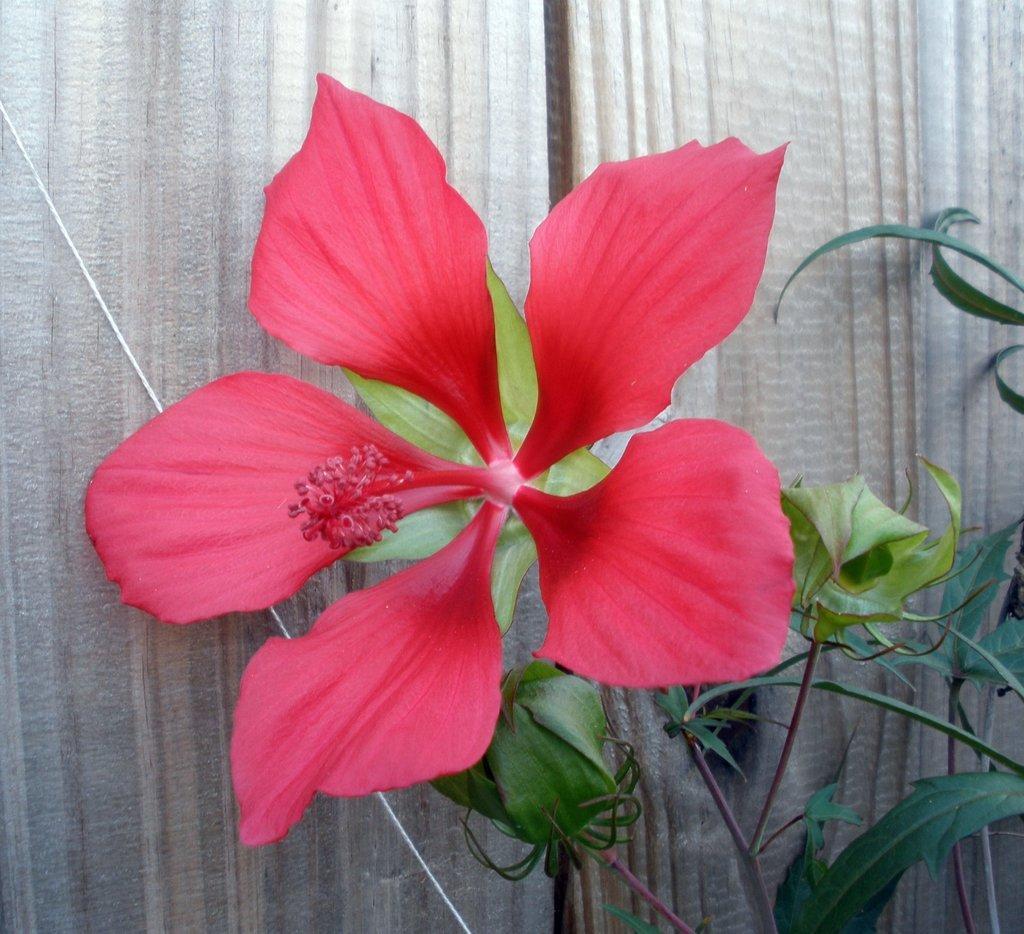Could you give a brief overview of what you see in this image? In this image we can see a hibiscus flower on a plant. In the back there are curtains. 